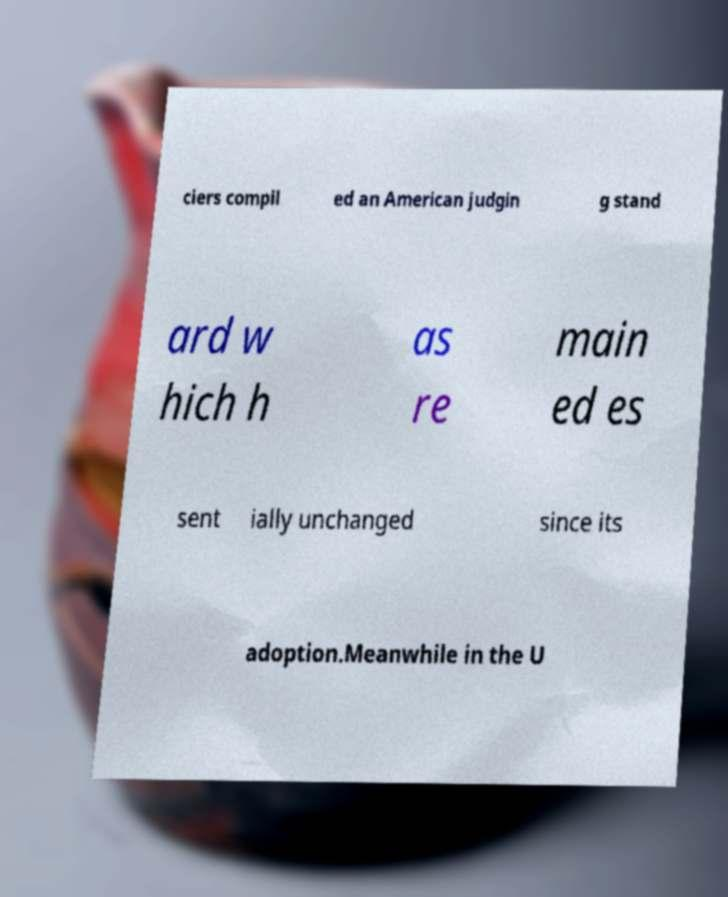Could you extract and type out the text from this image? ciers compil ed an American judgin g stand ard w hich h as re main ed es sent ially unchanged since its adoption.Meanwhile in the U 